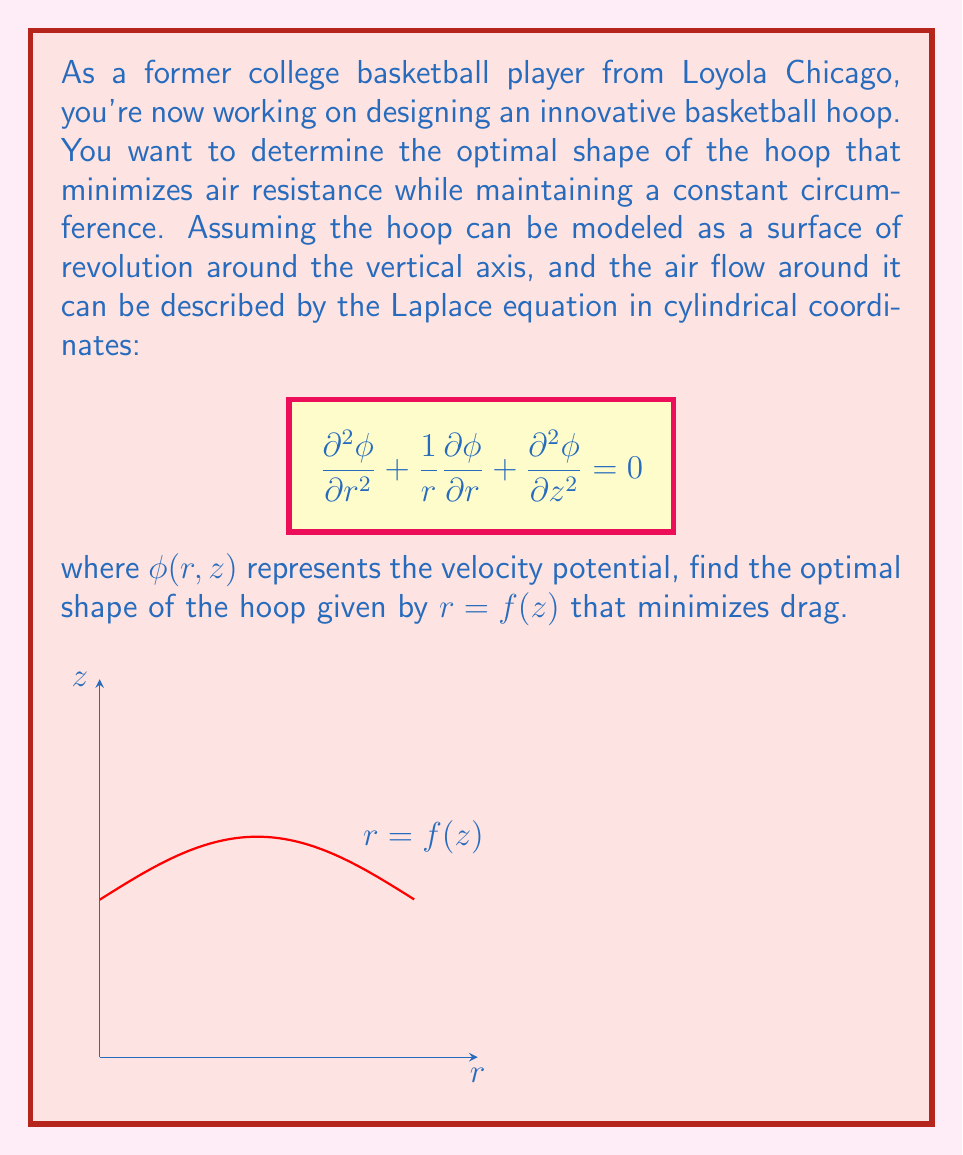Solve this math problem. To solve this problem, we'll follow these steps:

1) First, we need to recognize that minimizing air resistance is equivalent to minimizing the surface area of the hoop, given a constant circumference.

2) The surface area of a surface of revolution is given by:

   $$A = 2\pi \int_0^h r \sqrt{1 + (\frac{dr}{dz})^2} dz$$

   where $h$ is the height of the hoop.

3) The constraint of constant circumference can be expressed as:

   $$2\pi r = C$$

   where $C$ is a constant.

4) Using the calculus of variations, we can form the functional:

   $$J[r] = \int_0^h (r \sqrt{1 + (\frac{dr}{dz})^2} + \lambda r) dz$$

   where $\lambda$ is a Lagrange multiplier.

5) The Euler-Lagrange equation for this functional is:

   $$\frac{d}{dz}(\frac{\partial F}{\partial r'}) - \frac{\partial F}{\partial r} = 0$$

   where $F = r \sqrt{1 + (r')^2} + \lambda r$ and $r' = \frac{dr}{dz}$.

6) Solving this equation leads to:

   $$\frac{r''}{\sqrt{1+(r')^2}} + \frac{1}{r}(1+(r')^2) = 0$$

7) This differential equation has a solution of the form:

   $$r = a \cosh(\frac{z-b}{a})$$

   where $a$ and $b$ are constants determined by the boundary conditions.

8) This shape is known as a catenary, which when rotated around the z-axis forms a surface called a catenoid.

Therefore, the optimal shape of the basketball hoop that minimizes air resistance while maintaining a constant circumference is a section of a catenoid.
Answer: A section of a catenoid described by $r = a \cosh(\frac{z-b}{a})$. 